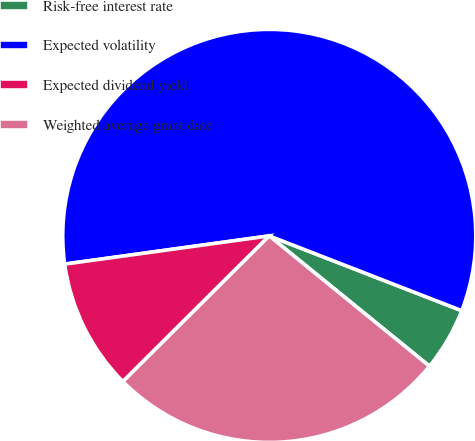<chart> <loc_0><loc_0><loc_500><loc_500><pie_chart><fcel>Risk-free interest rate<fcel>Expected volatility<fcel>Expected dividend yield<fcel>Weighted average grant date<nl><fcel>4.97%<fcel>58.08%<fcel>10.28%<fcel>26.67%<nl></chart> 